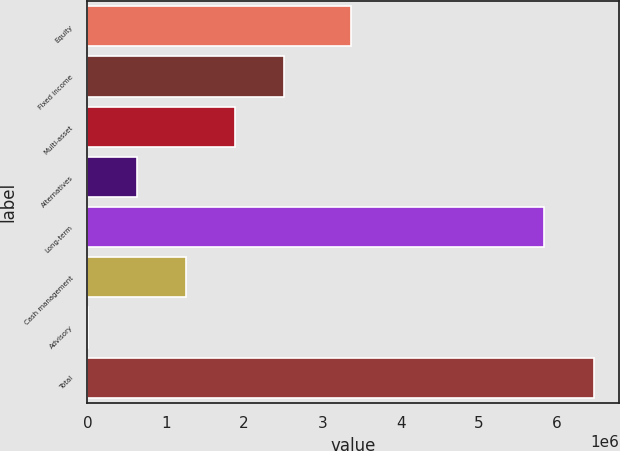<chart> <loc_0><loc_0><loc_500><loc_500><bar_chart><fcel>Equity<fcel>Fixed income<fcel>Multi-asset<fcel>Alternatives<fcel>Long-term<fcel>Cash management<fcel>Advisory<fcel>Total<nl><fcel>3.37164e+06<fcel>2.51619e+06<fcel>1.88752e+06<fcel>630183<fcel>5.83673e+06<fcel>1.25885e+06<fcel>1515<fcel>6.4654e+06<nl></chart> 